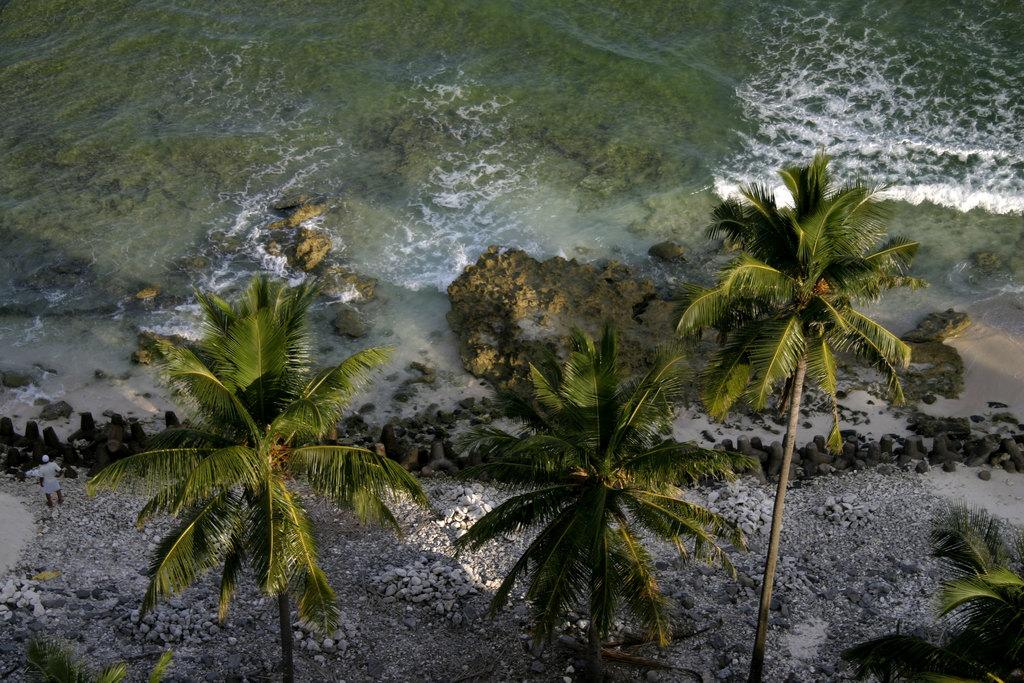What type of surface is near the water in the image? There is a sand surface near the water in the image. What can be found on the sand surface? There are rocks on the sand surface. How many coconut trees are in the image? There are three coconut trees in the image. Are there any rocks near the coconut trees? Yes, there are additional rocks on the surface near the coconut trees. What type of bun is being used to coil the impulse in the image? There is no bun, coil, or impulse present in the image. 